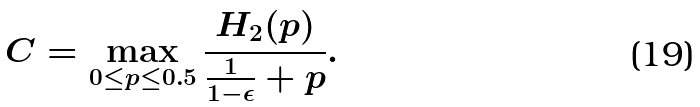<formula> <loc_0><loc_0><loc_500><loc_500>C & = \max _ { 0 \leq p \leq 0 . 5 } \frac { H _ { 2 } ( p ) } { \frac { 1 } { 1 - \epsilon } + p } .</formula> 